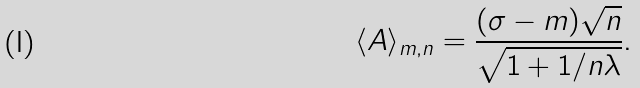<formula> <loc_0><loc_0><loc_500><loc_500>\langle A \rangle _ { m , n } = \frac { ( \sigma - m ) \sqrt { n } } { \sqrt { 1 + 1 / n \lambda } } .</formula> 